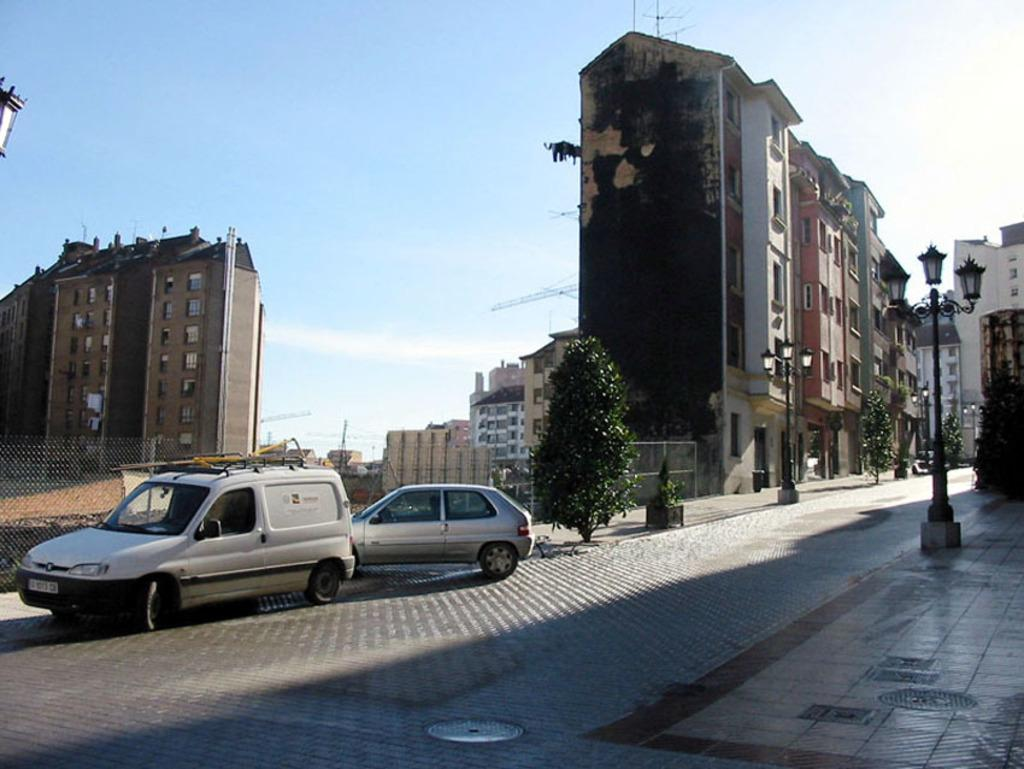What type of structures can be seen in the image? There are buildings in the image. What feature do the buildings have? The buildings have windows. What type of vegetation is present in the image? There are trees in the image. What type of vehicles can be seen in the image? There are cars in the image. What other objects can be seen in the image? There are poles in the image. Where is the coast visible in the image? There is no coast visible in the image; it features buildings, trees, cars, and poles. What type of wound can be seen on the pole in the image? There is no wound visible on any of the poles in the image. 